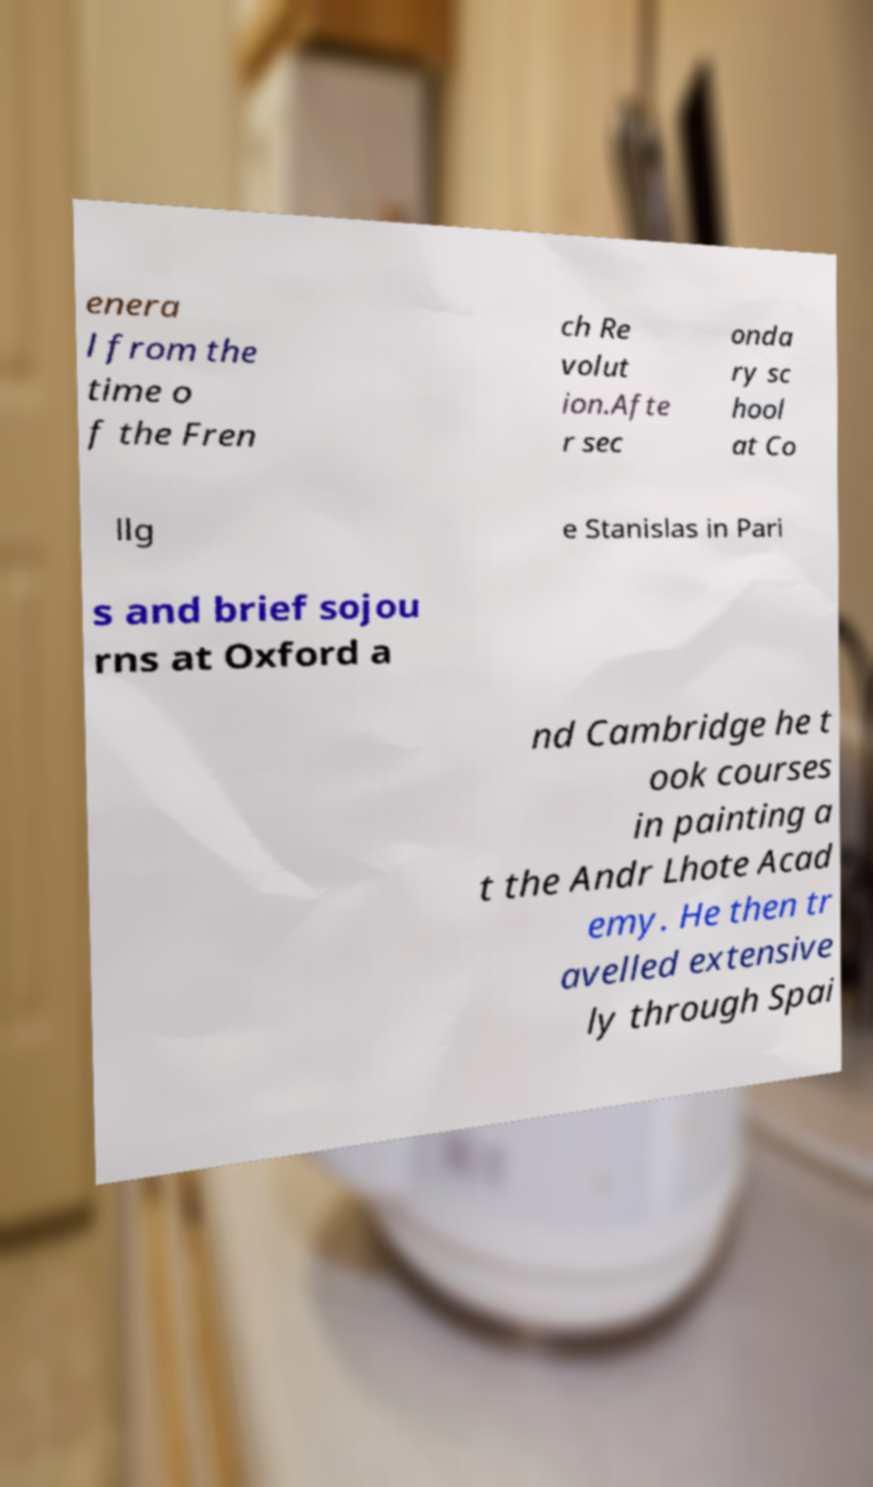Could you extract and type out the text from this image? enera l from the time o f the Fren ch Re volut ion.Afte r sec onda ry sc hool at Co llg e Stanislas in Pari s and brief sojou rns at Oxford a nd Cambridge he t ook courses in painting a t the Andr Lhote Acad emy. He then tr avelled extensive ly through Spai 